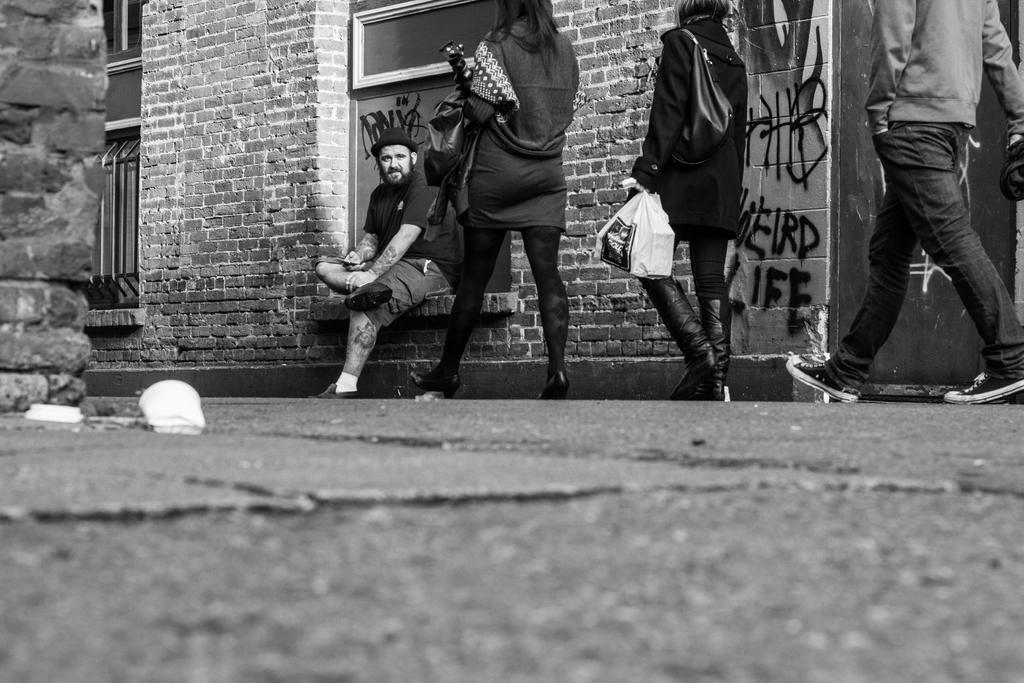What can be seen in the background of the image? There are buildings in the background of the image. What is the person in the image doing? A person is sitting in the image. How many people are walking in the image? Three people are walking in the image. What is the person sitting holding? The person sitting is holding a bag. What type of suit is the person sitting wearing in the image? There is no mention of a suit in the image; the person sitting is holding a bag. How many arrows are visible in the quiver of the person sitting in the image? There is no quiver or arrows present in the image; the person sitting is holding a bag. 